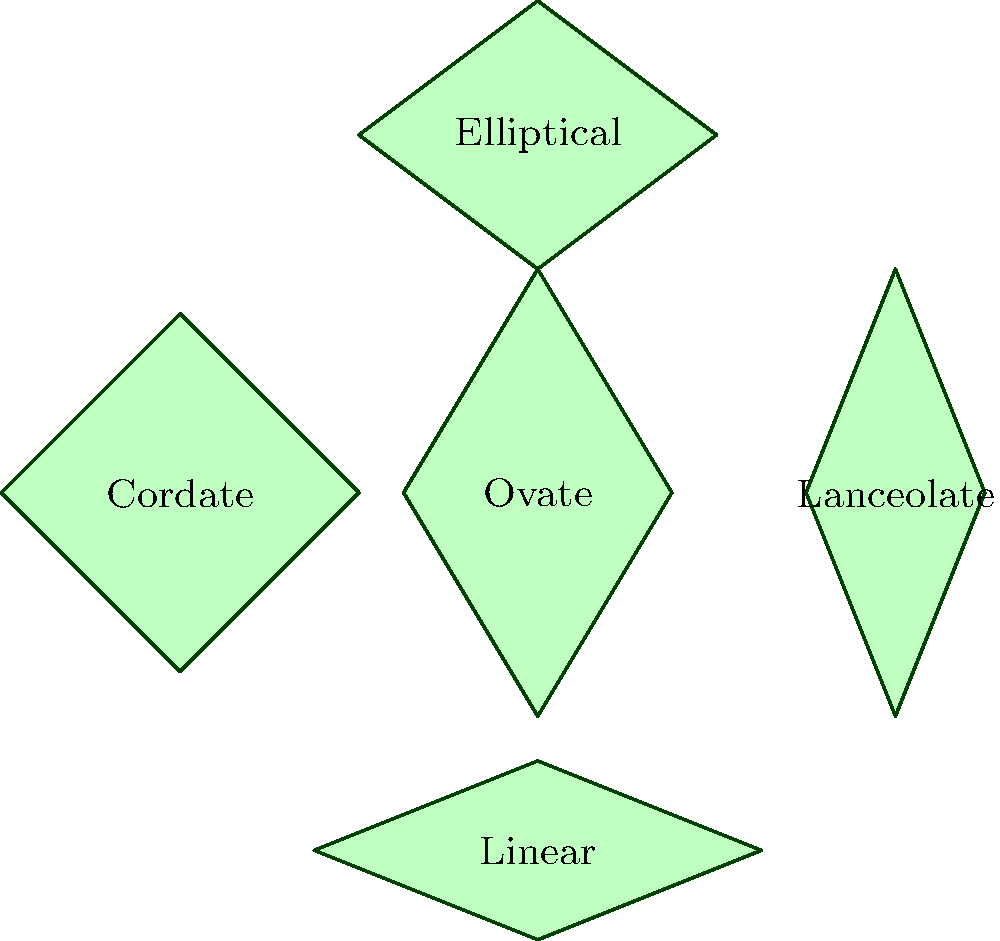In this plant identification chart, which leaf shape is characterized by a narrow, elongated form with nearly parallel sides and is commonly found in grasses? To identify the correct leaf shape, let's examine each shape in the chart:

1. Ovate (center): Egg-shaped, wider at the base and tapering towards the tip.
2. Lanceolate (right): Lance-shaped, longer than it is wide, tapering to a point at both ends.
3. Cordate (left): Heart-shaped, with a notched base.
4. Linear (bottom): Narrow and elongated with nearly parallel sides.
5. Elliptical (top): Oval-shaped with rounded ends.

The question asks for a narrow, elongated form with nearly parallel sides, commonly found in grasses. This description perfectly matches the Linear leaf shape, which is located at the bottom of the chart.

Linear leaves are characterized by their long, narrow form with edges that run almost parallel to each other for most of the leaf's length. This shape is indeed common in many grass species, making it an important shape for plant identification, especially for a plant influencer who often shares plant care tips and photographs.
Answer: Linear 